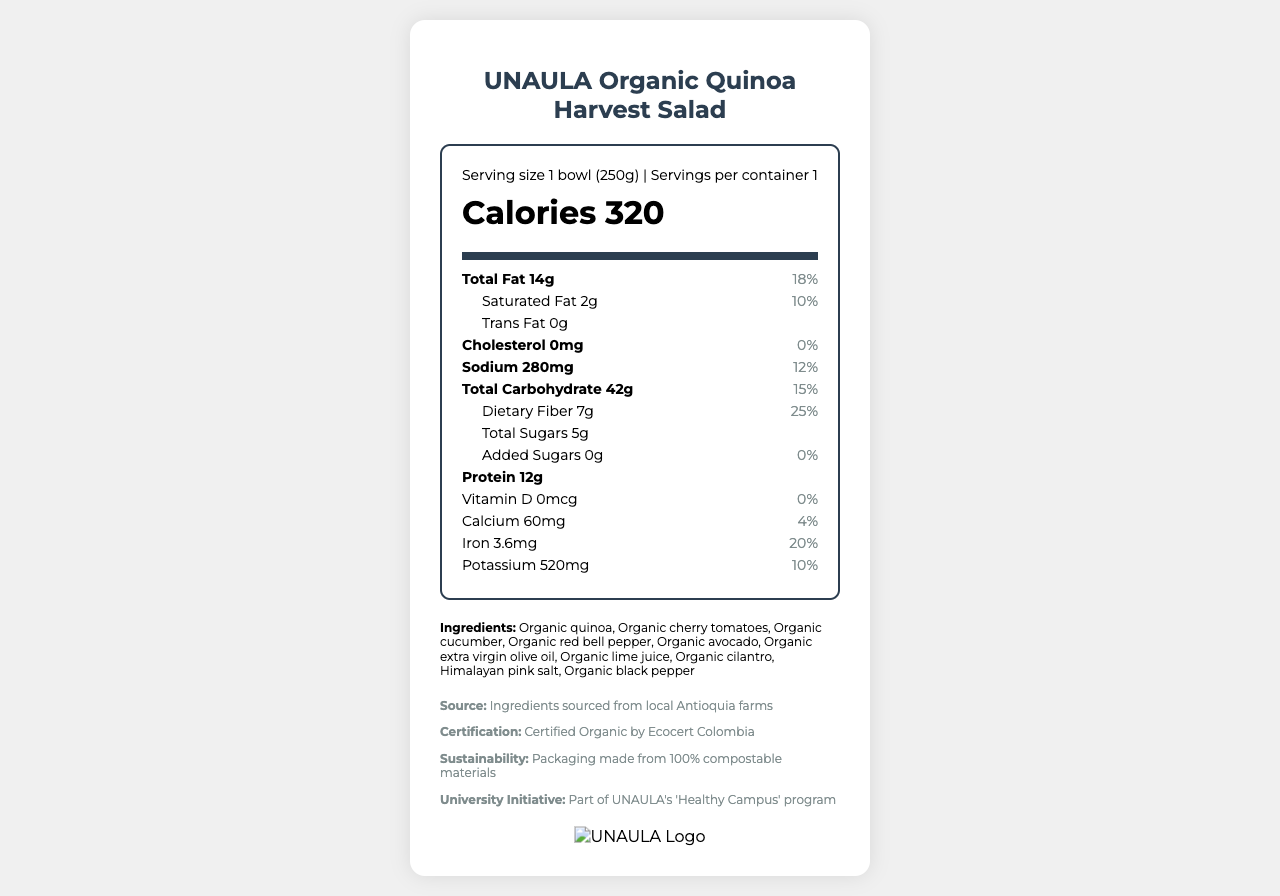who certified the salad as organic? The additional info section states that the salad is "Certified Organic by Ecocert Colombia."
Answer: Ecocert Colombia what is the serving size of the UNAULA Organic Quinoa Harvest Salad? The serving size is mentioned in the nutrition label section as "Serving size 1 bowl (250g)".
Answer: 1 bowl (250g) how much protein does the quinoa salad provide per serving? The protein amount per serving is listed in the nutrient information as "Protein 12g".
Answer: 12g what is the daily value percentage of dietary fiber in the quinoa salad? The daily value percentage for dietary fiber is specified as "Dietary Fiber 7g, 25%".
Answer: 25% does the quinoa salad contain any added sugars? The nutrient information shows "Added Sugars 0g, 0%", indicating no added sugars.
Answer: No how many calories are in one serving of the quinoa salad? The calorie content is stated clearly in the nutrition label as "Calories 320".
Answer: 320 what types of fat are included in the quinoa salad? The types of fat and their amounts are listed under the nutrient rows, specifying "Total Fat 14g," "Saturated Fat 2g," and "Trans Fat 0g".
Answer: Total fat 14g (Saturated fat 2g, Trans fat 0g) where are the ingredients for the quinoa salad sourced from? The additional info section mentions "Ingredients sourced from local Antioquia farms."
Answer: Antioquia farms which of the following is not an ingredient in the salad? A. Organic avocado B. Organic black beans C. Organic quinoa The ingredients list includes Organic avocado and Organic quinoa, but not Organic black beans.
Answer: B. Organic black beans what are the sources of vitamins and minerals in the salad? A. Vitamin D B. Calcium C. Iron D. Potassium The nutrition label lists Calcium, Iron, and Potassium amounts but has 0% daily value for Vitamin D.
Answer: A. None B. Calcium (60mg) C. Iron (3.6mg) D. Potassium (520mg) is the packaging of the quinoa salad compostable? The additional info indicates that "Packaging made from 100% compostable materials".
Answer: Yes does the salad contain any allergens? The allergens section states "None".
Answer: No summarize the main information of the document regarding the quinoa salad. The document includes detailed nutritional information, ingredient sourcing, sustainability initiatives, and highlights the university's "Healthy Campus" program.
Answer: The UNAULA Organic Quinoa Harvest Salad consists of locally sourced organic ingredients, including quinoa, cherry tomatoes, cucumber, and avocado. It provides significant nutritional benefits such as 320 calories, 12g protein, and 25% daily value of dietary fiber per serving. It is free from added sugars and trans fats and carries certifications for being organic and environmentally sustainable. how much sodium does the quinoa salad contain per serving? The amount of sodium per serving is stated in the nutrition label as "Sodium 280mg".
Answer: 280mg is this salad part of any university program? If yes, name the program. The additional info mentions that the salad is "Part of UNAULA's 'Healthy Campus' program."
Answer: Yes, "Healthy Campus" program how much iron does the quinoa salad provide, and what percentage of the daily value does it cover? The nutrient information indicates "Iron 3.6mg, 20%."
Answer: 3.6mg, 20% was the salad prepared using organic red bell pepper? The ingredients list includes "Organic red bell pepper."
Answer: Yes what is the source of the quinoa used in the salad? The document states that the ingredients are sourced from local Antioquia farms but does not specify the exact source of the quinoa itself.
Answer: Cannot be determined 